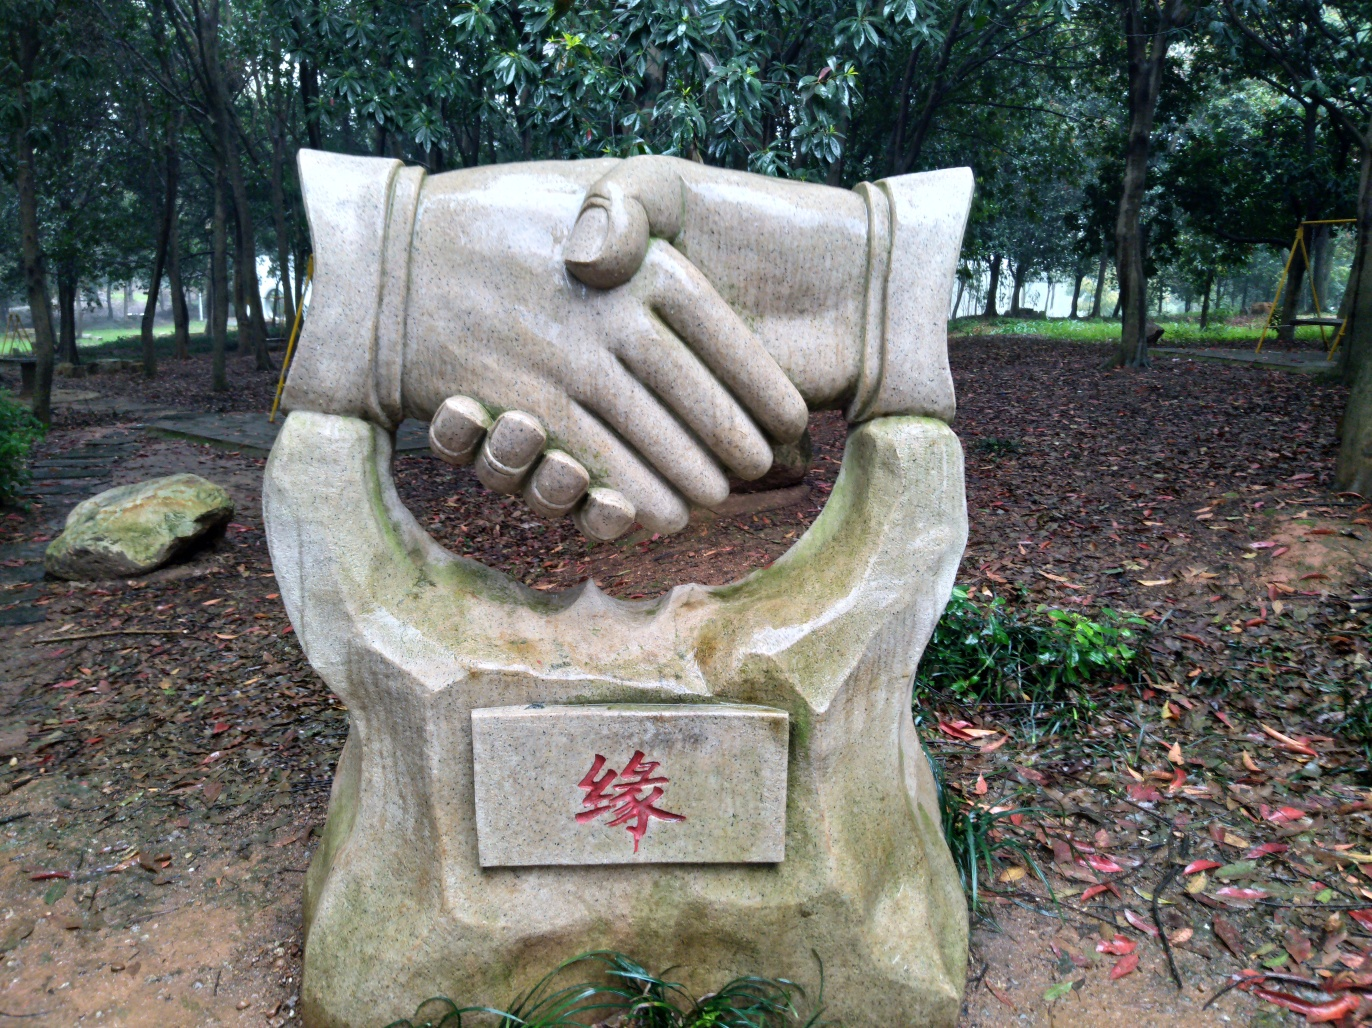What does the plaque on the sculpture represent? Plaques on sculptures often bear inscriptions that explain the sculpture's meaning, the artist's name, or the date of installation. It can also include a dedication or acknowledgment to a person or group, although without a clear view, the specifics of this plaque's text remain unknown. In which type of setting would you typically find this sculpture, and why? Such sculptures are commonly placed in parks, educational institutions, or community centers where they can be appreciated by many and where their symbolic value aligns with a shared vision or ethos. The accessibility and visibility of the location are key factors for communal engagement and the sculpture's integrative intent. 